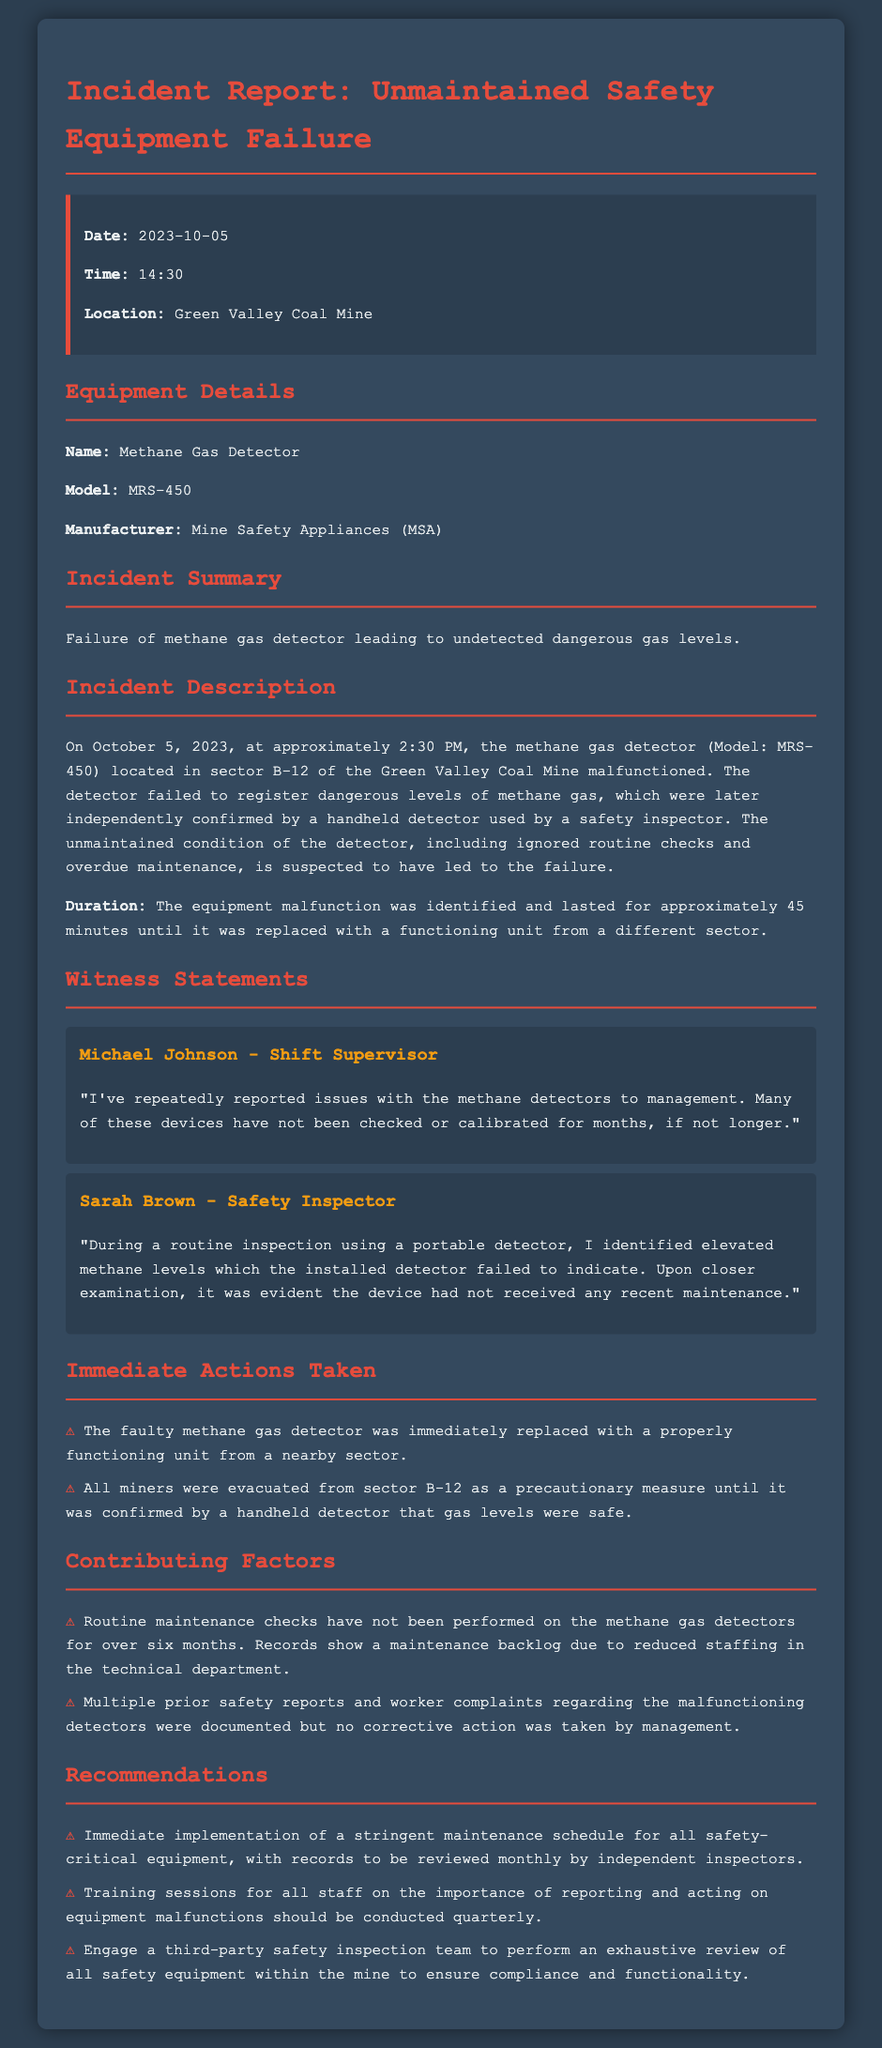what is the date of the incident? The date of the incident is explicitly mentioned in the report as October 5, 2023.
Answer: October 5, 2023 what time did the incident occur? The time of the incident is clearly stated as 14:30 in the report.
Answer: 14:30 what equipment failed during the incident? The report identifies the specific equipment that failed as the methane gas detector.
Answer: Methane Gas Detector how long did the equipment malfunction last? The duration of the malfunction is mentioned in the report to last approximately 45 minutes.
Answer: 45 minutes who reported issues with the methane detectors? The statement of the shift supervisor indicates he is the one who repeatedly reported issues with the methane detectors.
Answer: Michael Johnson what was the manufacturer's name of the failed equipment? The manufacturer of the methane gas detector is listed as Mine Safety Appliances.
Answer: Mine Safety Appliances what immediate action was taken after the failure? The report indicates that the faulty methane gas detector was immediately replaced with a properly functioning unit.
Answer: Replaced with a properly functioning unit what were the contributing factors to the equipment failure? The document lists lack of routine maintenance checks and prior safety reports without corrective actions as contributing factors.
Answer: Lack of routine maintenance checks and prior safety reports without corrective actions what is one of the recommendations made in the report? The report recommends the immediate implementation of a stringent maintenance schedule for safety-critical equipment.
Answer: Implementation of a stringent maintenance schedule 